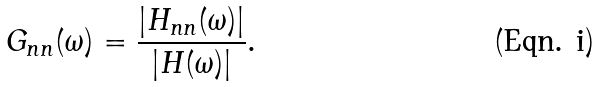Convert formula to latex. <formula><loc_0><loc_0><loc_500><loc_500>G _ { n n } ( \omega ) = \frac { | H _ { n n } ( \omega ) | } { | H ( \omega ) | } .</formula> 